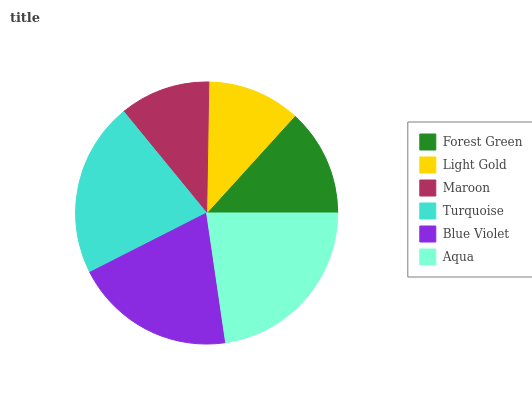Is Maroon the minimum?
Answer yes or no. Yes. Is Aqua the maximum?
Answer yes or no. Yes. Is Light Gold the minimum?
Answer yes or no. No. Is Light Gold the maximum?
Answer yes or no. No. Is Forest Green greater than Light Gold?
Answer yes or no. Yes. Is Light Gold less than Forest Green?
Answer yes or no. Yes. Is Light Gold greater than Forest Green?
Answer yes or no. No. Is Forest Green less than Light Gold?
Answer yes or no. No. Is Blue Violet the high median?
Answer yes or no. Yes. Is Forest Green the low median?
Answer yes or no. Yes. Is Light Gold the high median?
Answer yes or no. No. Is Light Gold the low median?
Answer yes or no. No. 